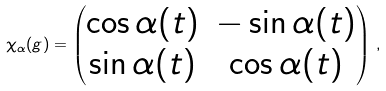<formula> <loc_0><loc_0><loc_500><loc_500>\chi _ { \alpha } ( g ) = \begin{pmatrix} \cos { \alpha ( t ) } & - \sin { \alpha ( t ) } \\ \sin { \alpha ( t ) } & \cos { \alpha ( t ) } \end{pmatrix} \, ,</formula> 